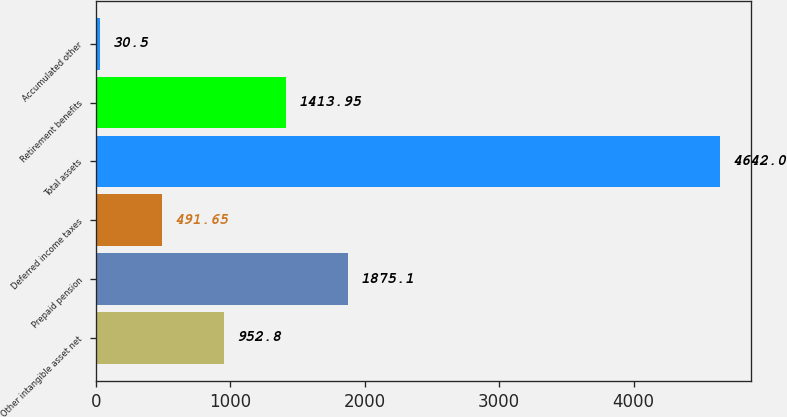Convert chart to OTSL. <chart><loc_0><loc_0><loc_500><loc_500><bar_chart><fcel>Other intangible asset net<fcel>Prepaid pension<fcel>Deferred income taxes<fcel>Total assets<fcel>Retirement benefits<fcel>Accumulated other<nl><fcel>952.8<fcel>1875.1<fcel>491.65<fcel>4642<fcel>1413.95<fcel>30.5<nl></chart> 